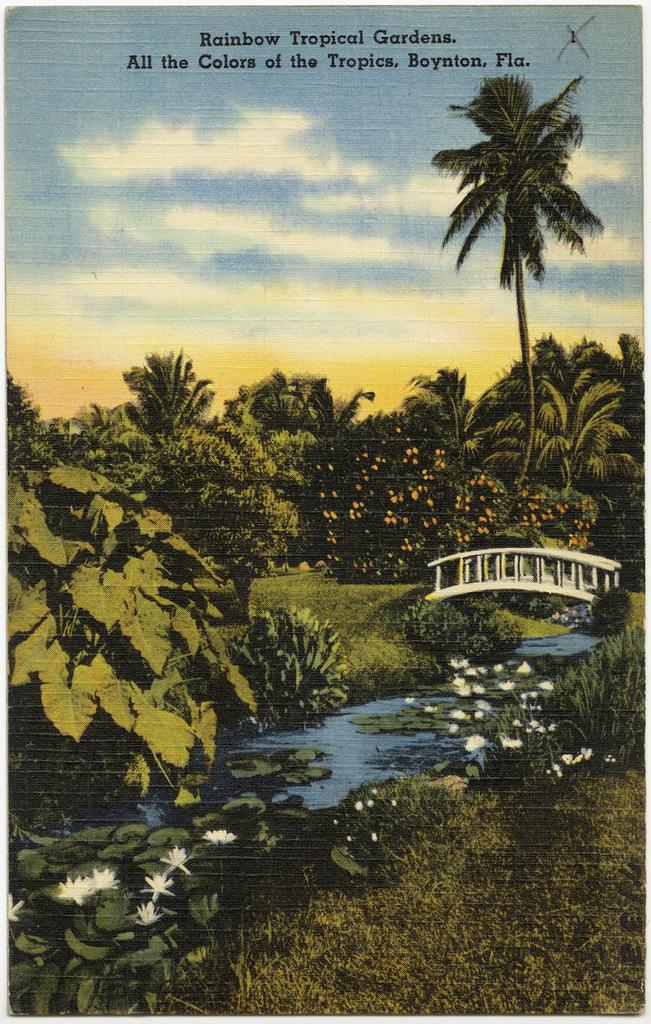What type of vegetation can be seen in the image? There are trees and flower plants in the image. What is the ground covered with in the image? There is grass in the image. What is the water feature in the image? There is water in the image. What structure is present in the image? There is a bridge in the image. What is visible in the sky in the image? The sky is visible in the image, and there are clouds in the sky. What is written at the top of the image? There is text at the top of the image. How does the crowd behave in the image? There is no crowd present in the image; it features trees, flower plants, grass, water, a bridge, the sky, clouds, and text. 